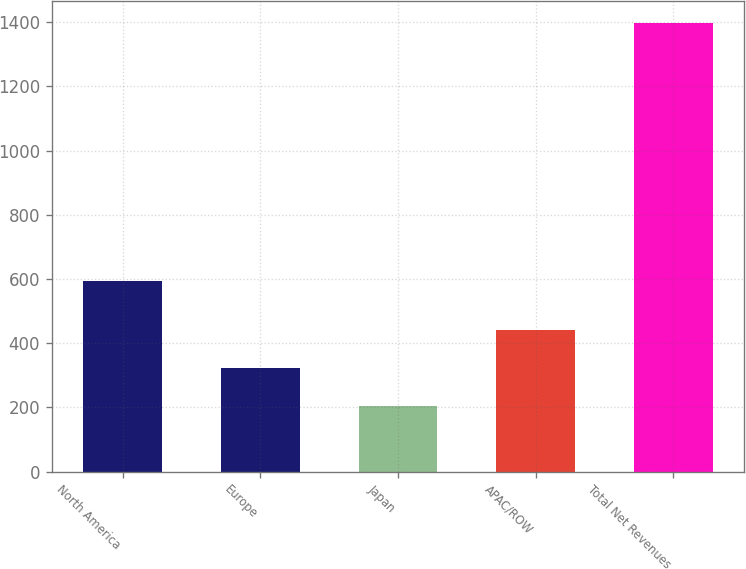Convert chart. <chart><loc_0><loc_0><loc_500><loc_500><bar_chart><fcel>North America<fcel>Europe<fcel>Japan<fcel>APAC/ROW<fcel>Total Net Revenues<nl><fcel>592.5<fcel>323.02<fcel>203.6<fcel>442.44<fcel>1397.8<nl></chart> 